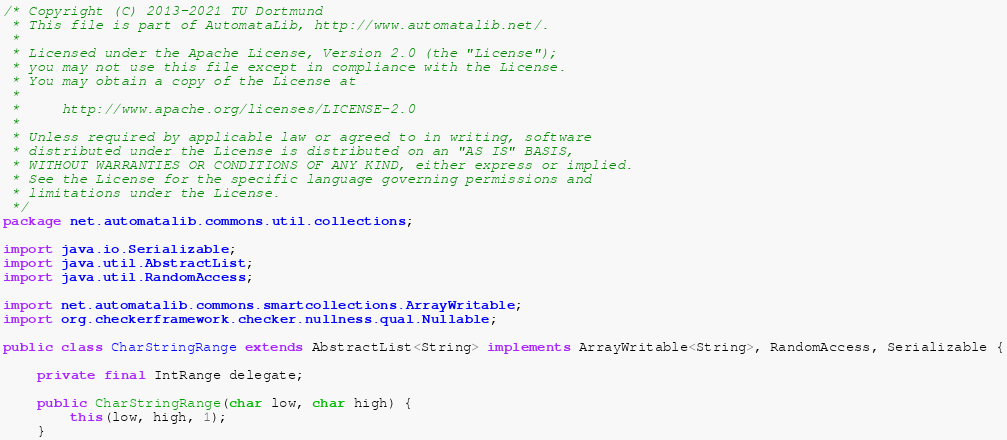<code> <loc_0><loc_0><loc_500><loc_500><_Java_>/* Copyright (C) 2013-2021 TU Dortmund
 * This file is part of AutomataLib, http://www.automatalib.net/.
 *
 * Licensed under the Apache License, Version 2.0 (the "License");
 * you may not use this file except in compliance with the License.
 * You may obtain a copy of the License at
 *
 *     http://www.apache.org/licenses/LICENSE-2.0
 *
 * Unless required by applicable law or agreed to in writing, software
 * distributed under the License is distributed on an "AS IS" BASIS,
 * WITHOUT WARRANTIES OR CONDITIONS OF ANY KIND, either express or implied.
 * See the License for the specific language governing permissions and
 * limitations under the License.
 */
package net.automatalib.commons.util.collections;

import java.io.Serializable;
import java.util.AbstractList;
import java.util.RandomAccess;

import net.automatalib.commons.smartcollections.ArrayWritable;
import org.checkerframework.checker.nullness.qual.Nullable;

public class CharStringRange extends AbstractList<String> implements ArrayWritable<String>, RandomAccess, Serializable {

    private final IntRange delegate;

    public CharStringRange(char low, char high) {
        this(low, high, 1);
    }
</code> 